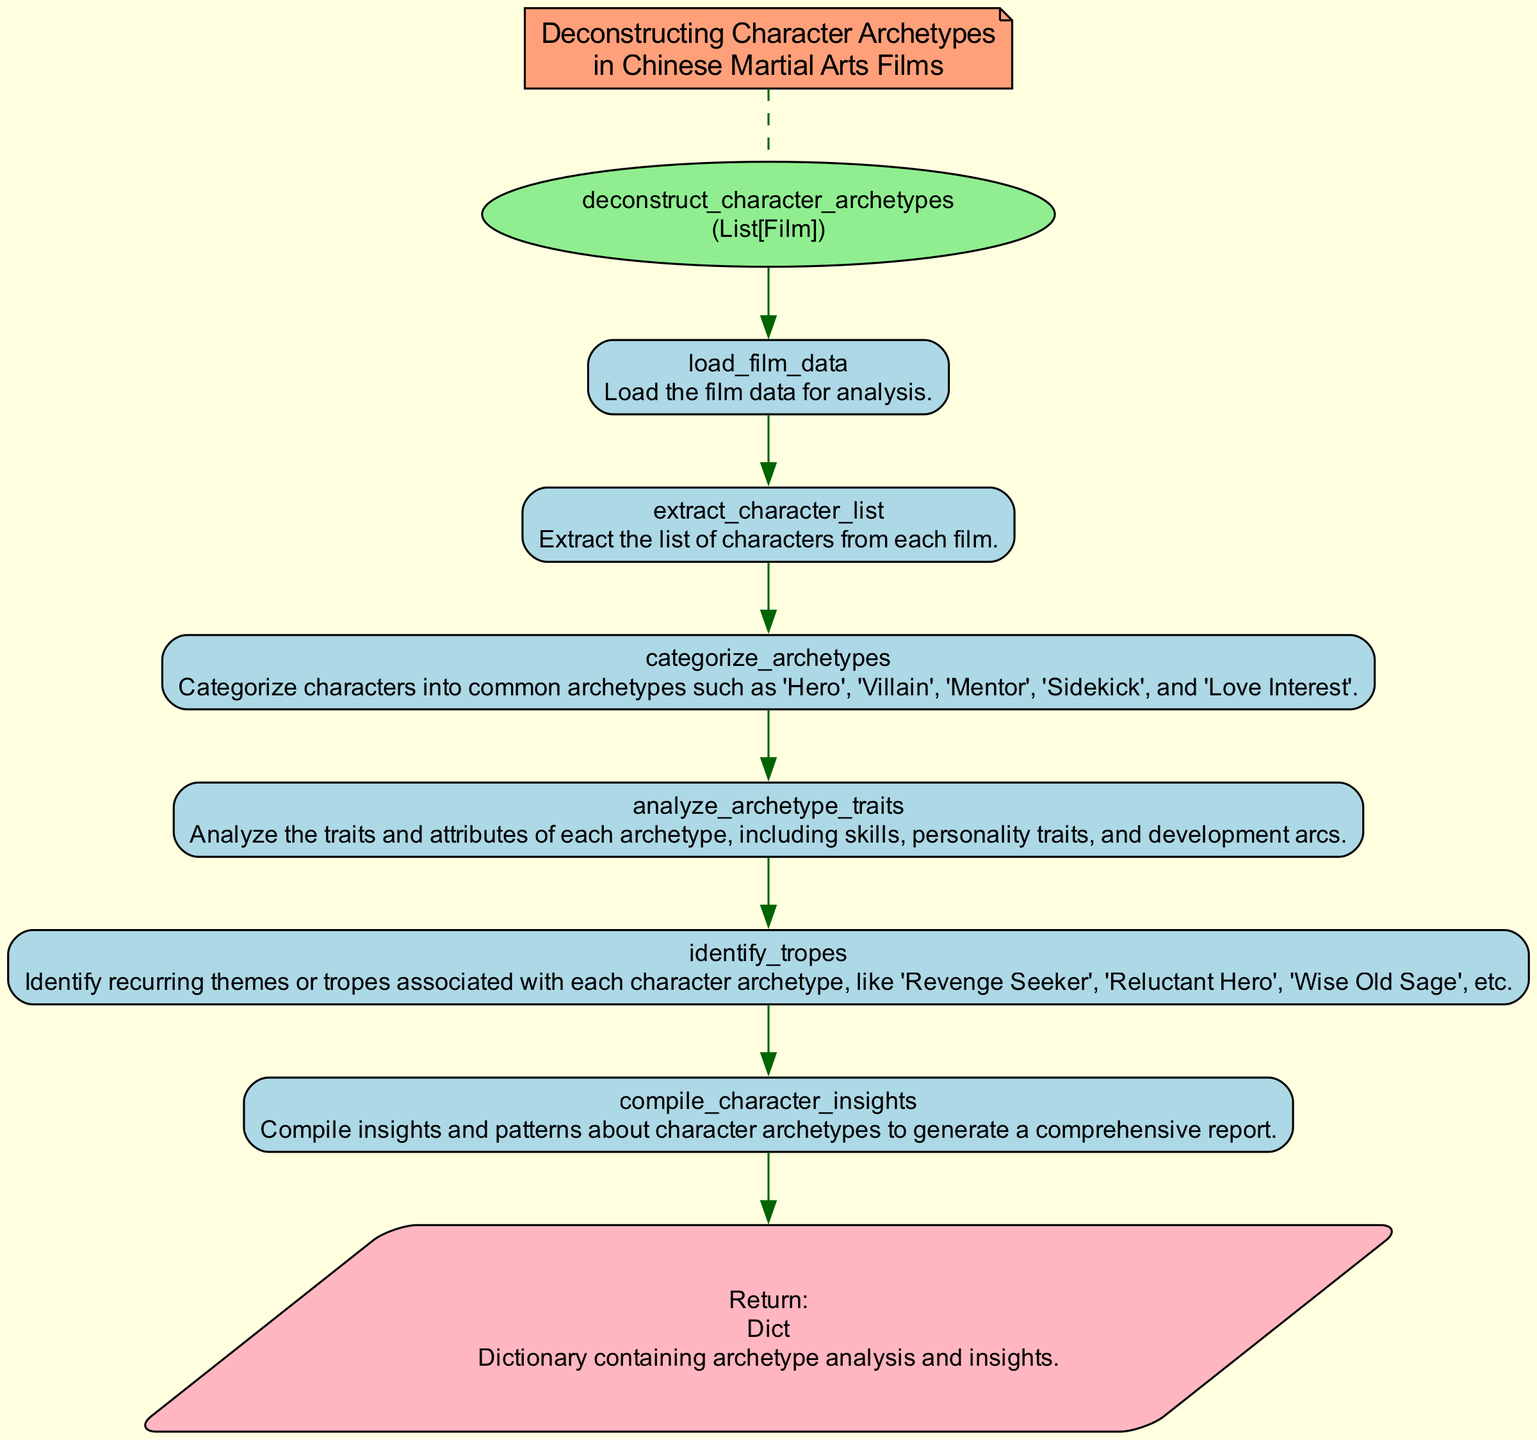What is the function name in the diagram? The diagram reveals that the name of the function is "deconstruct_character_archetypes". This is clearly stated at the top of the flowchart within the ellipse representing the function.
Answer: deconstruct_character_archetypes How many steps are there in the function flowchart? The diagram outlines a total of six distinct steps involved in the function's process. Each step is represented by a separate rectangle connected sequentially.
Answer: 6 What step comes directly after "extract_character_list"? In the flowchart, "categorize_archetypes" is shown as the step that follows "extract_character_list", indicating the sequential progression of the function.
Answer: categorize_archetypes What does the final node return? The final node indicates that the function returns a dictionary containing archetype analysis and insights, which is specified clearly within the parallelogram shape representing the return value.
Answer: Dictionary containing archetype analysis and insights Which step identifies recurring themes or tropes? The step that identifies recurring themes or tropes is labeled as "identify_tropes", which shows its specific function in analyzing character archetypes. This step is positioned before the final report generation.
Answer: identify_tropes Which shape is used to represent the steps in the flowchart? The steps in the flowchart are represented by rectangles, which are filled with light blue color and rounded edges as designated in the diagram attributes.
Answer: Rectangle Which nodes are connected by a dashed edge? The dashed edge connects the note node labeled "Deconstructing Character Archetypes in Chinese Martial Arts Films" to the function node. This indicates a supplementary note about the context of the flowchart.
Answer: Note to function What is the primary focus of the function? The primary focus of the function, as indicated in the notated section, is to analyze character archetypes in Chinese martial arts films. This is highlighted before the function node in the diagram.
Answer: Character archetypes in Chinese martial arts films What type of information is analyzed in the step "analyze_archetype_traits"? The step "analyze_archetype_traits" involves analyzing traits and attributes of each archetype, which includes aspects like skills, personality traits, and development arcs, as described in the flowchart.
Answer: Traits and attributes of archetypes 